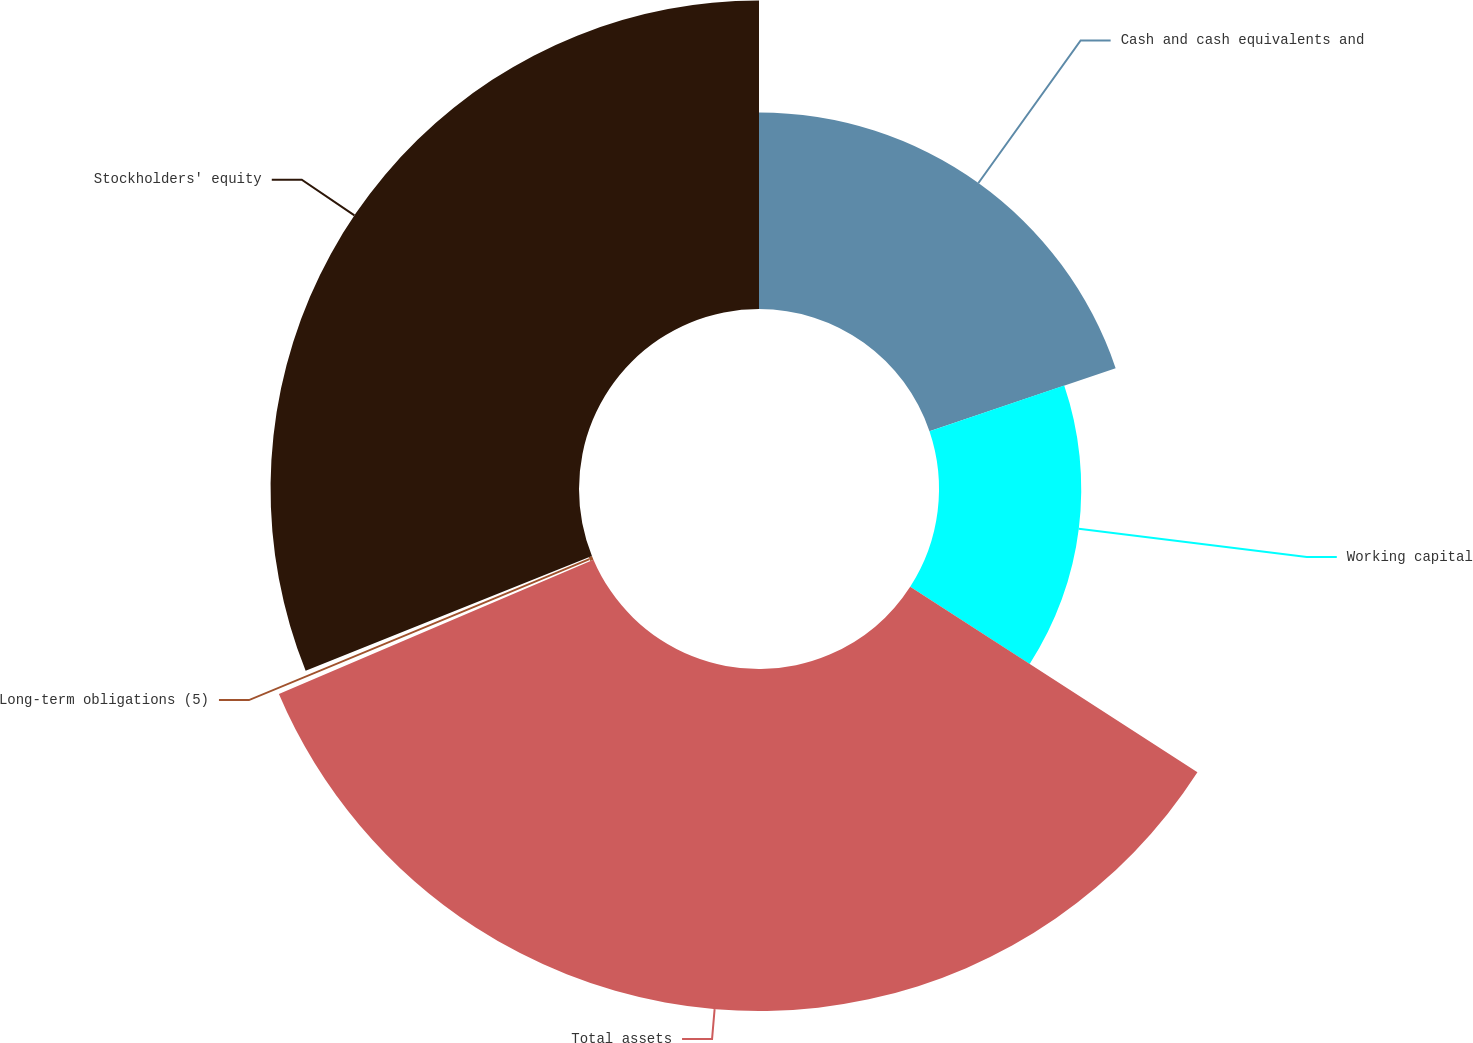<chart> <loc_0><loc_0><loc_500><loc_500><pie_chart><fcel>Cash and cash equivalents and<fcel>Working capital<fcel>Total assets<fcel>Long-term obligations (5)<fcel>Stockholders' equity<nl><fcel>19.8%<fcel>14.33%<fcel>34.45%<fcel>0.35%<fcel>31.07%<nl></chart> 